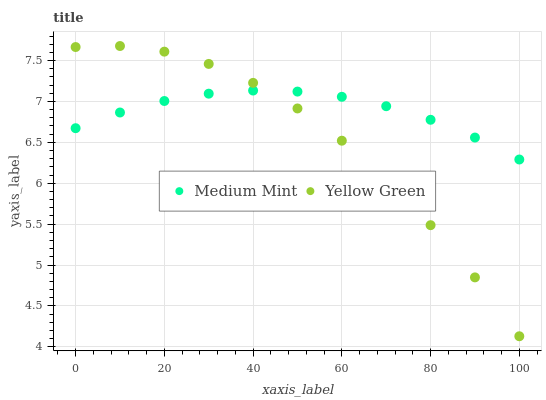Does Yellow Green have the minimum area under the curve?
Answer yes or no. Yes. Does Medium Mint have the maximum area under the curve?
Answer yes or no. Yes. Does Yellow Green have the maximum area under the curve?
Answer yes or no. No. Is Medium Mint the smoothest?
Answer yes or no. Yes. Is Yellow Green the roughest?
Answer yes or no. Yes. Is Yellow Green the smoothest?
Answer yes or no. No. Does Yellow Green have the lowest value?
Answer yes or no. Yes. Does Yellow Green have the highest value?
Answer yes or no. Yes. Does Yellow Green intersect Medium Mint?
Answer yes or no. Yes. Is Yellow Green less than Medium Mint?
Answer yes or no. No. Is Yellow Green greater than Medium Mint?
Answer yes or no. No. 